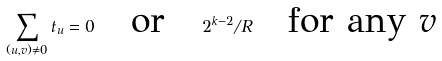<formula> <loc_0><loc_0><loc_500><loc_500>\sum _ { ( u , v ) \not = 0 } t _ { u } = 0 \quad \text {or} \quad 2 ^ { k - 2 } / R \quad \text {for any $v$}</formula> 